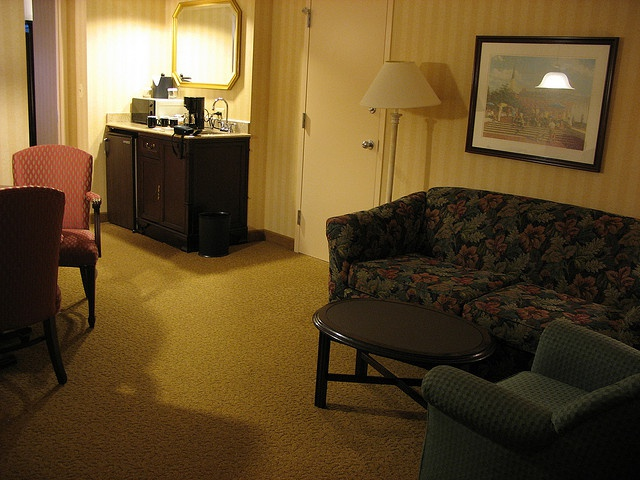Describe the objects in this image and their specific colors. I can see couch in olive, black, maroon, and tan tones, chair in olive, black, and darkgreen tones, chair in black, maroon, and olive tones, chair in olive, brown, black, and maroon tones, and refrigerator in olive, black, and maroon tones in this image. 